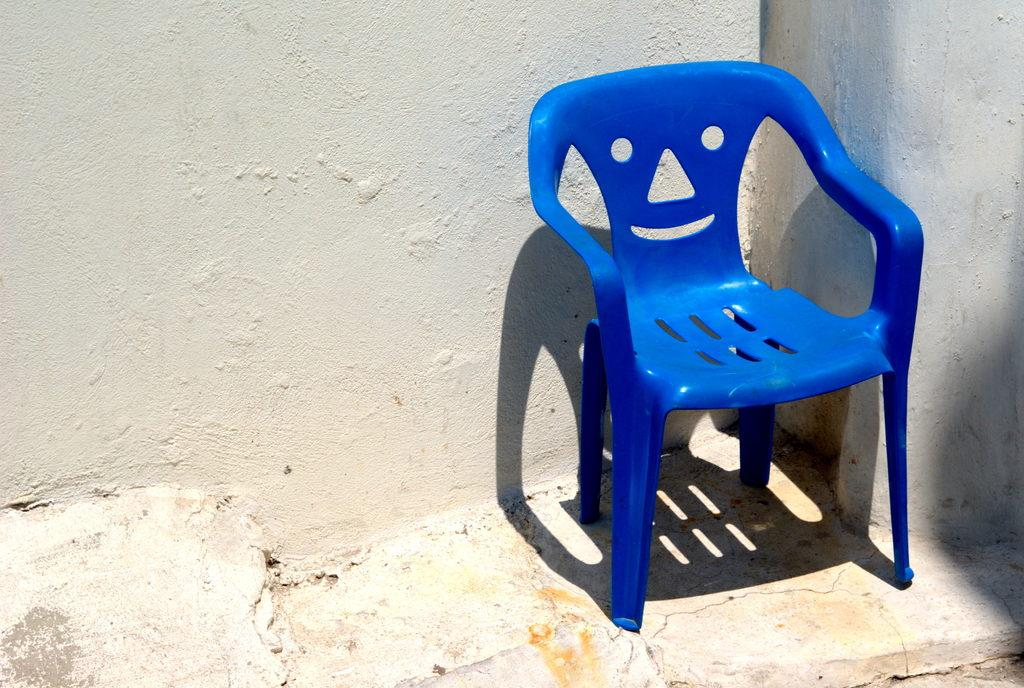What color is the chair in the image? The chair in the image is blue. Where is the chair located in relation to the ground? The chair is on the ground. What can be seen in the background of the image? There is a wall visible in the background of the image. What type of skirt is being worn by the chair in the image? There is no skirt present in the image, as the subject is a chair and not a person. 